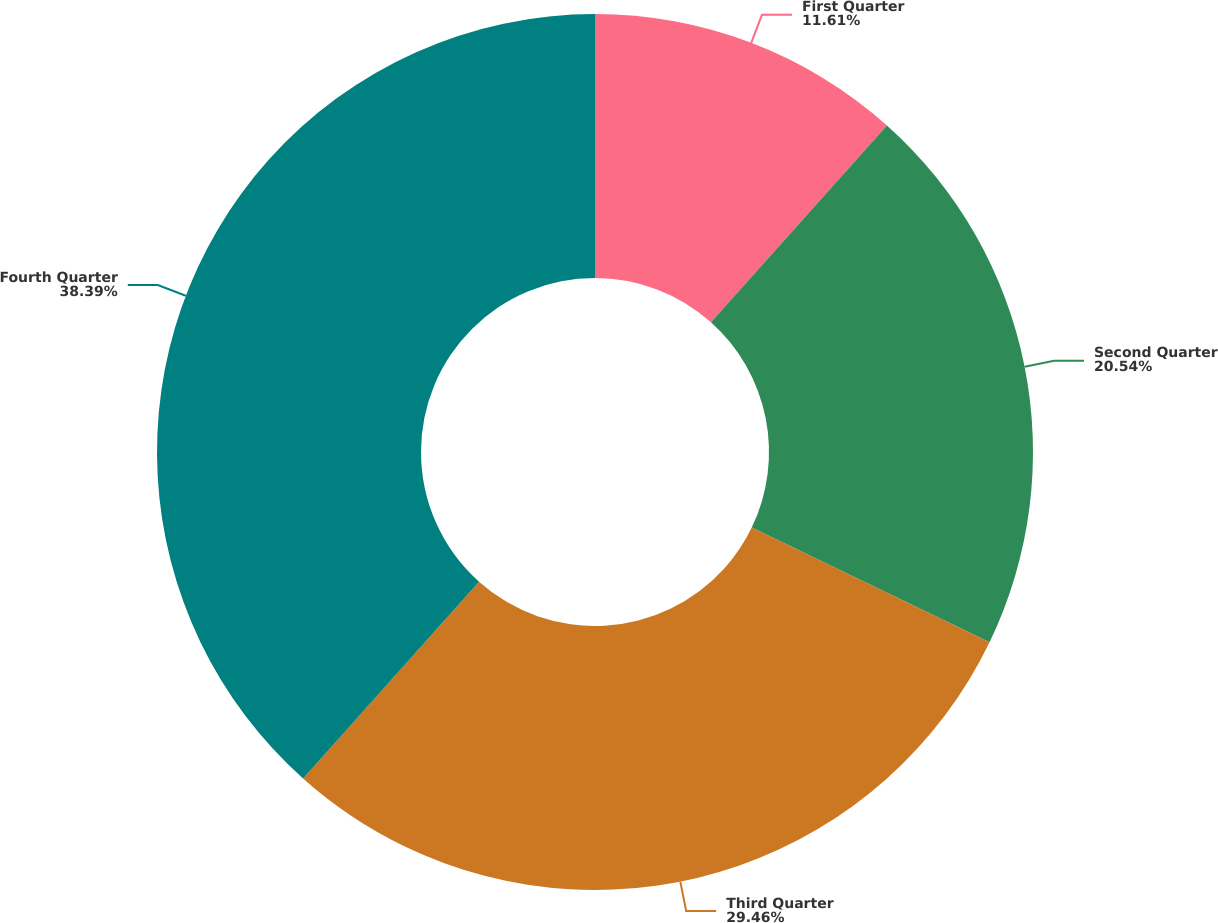Convert chart to OTSL. <chart><loc_0><loc_0><loc_500><loc_500><pie_chart><fcel>First Quarter<fcel>Second Quarter<fcel>Third Quarter<fcel>Fourth Quarter<nl><fcel>11.61%<fcel>20.54%<fcel>29.46%<fcel>38.39%<nl></chart> 